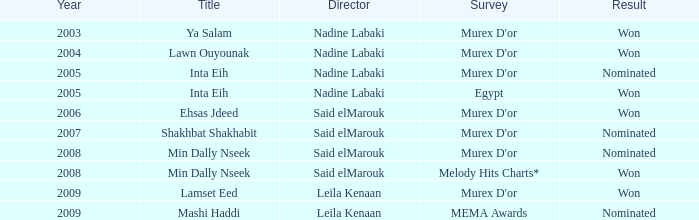What is the ehsas jdeed title referring to in terms of a survey? Murex D'or. 